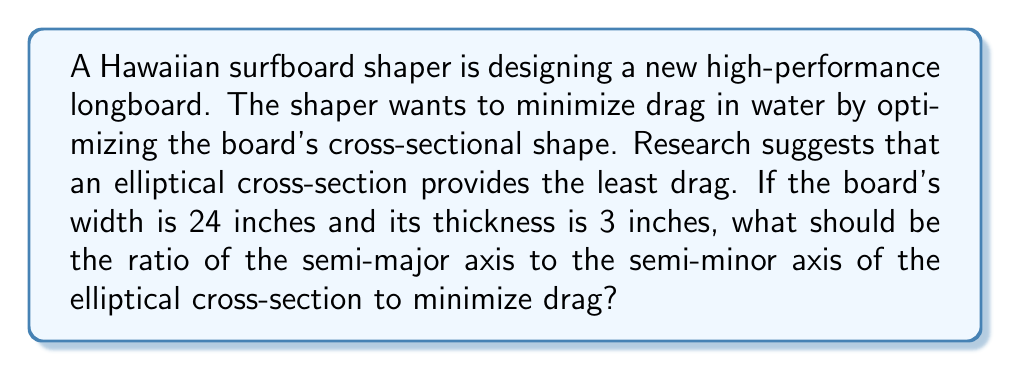Could you help me with this problem? To solve this problem, we need to understand the relationship between drag and the shape of an object moving through water. For an elliptical cross-section, the drag coefficient is minimized when the ratio of the semi-major axis to the semi-minor axis is approximately 4:1.

Let's define our variables:
$a$ = semi-major axis (half of the width)
$b$ = semi-minor axis (half of the thickness)

Given:
Width = 24 inches, so $a = 12$ inches
Thickness = 3 inches, so $b = 1.5$ inches

To find the optimal ratio, we need to calculate:

$$\frac{a}{b} = \frac{12}{1.5} = 8$$

This ratio of 8:1 is higher than the optimal 4:1 ratio for minimizing drag. To achieve the optimal ratio, we need to adjust the semi-minor axis while keeping the semi-major axis constant (as the width is fixed).

Let $x$ be the optimal semi-minor axis:

$$\frac{a}{x} = 4$$

Solving for $x$:

$$x = \frac{a}{4} = \frac{12}{4} = 3 \text{ inches}$$

This means the optimal thickness of the board should be $2x = 6$ inches. However, the given thickness is only 3 inches.

Since we can't change the actual dimensions of the board, we need to find the best approximation of the 4:1 ratio given the constraints. The current ratio of 8:1 is the closest we can get to the optimal 4:1 ratio without changing the board's dimensions.

Therefore, the optimal ratio for minimizing drag, given the constraints, is 8:1.
Answer: The optimal ratio of the semi-major axis to the semi-minor axis for minimizing drag, given the constraints, is 8:1. 